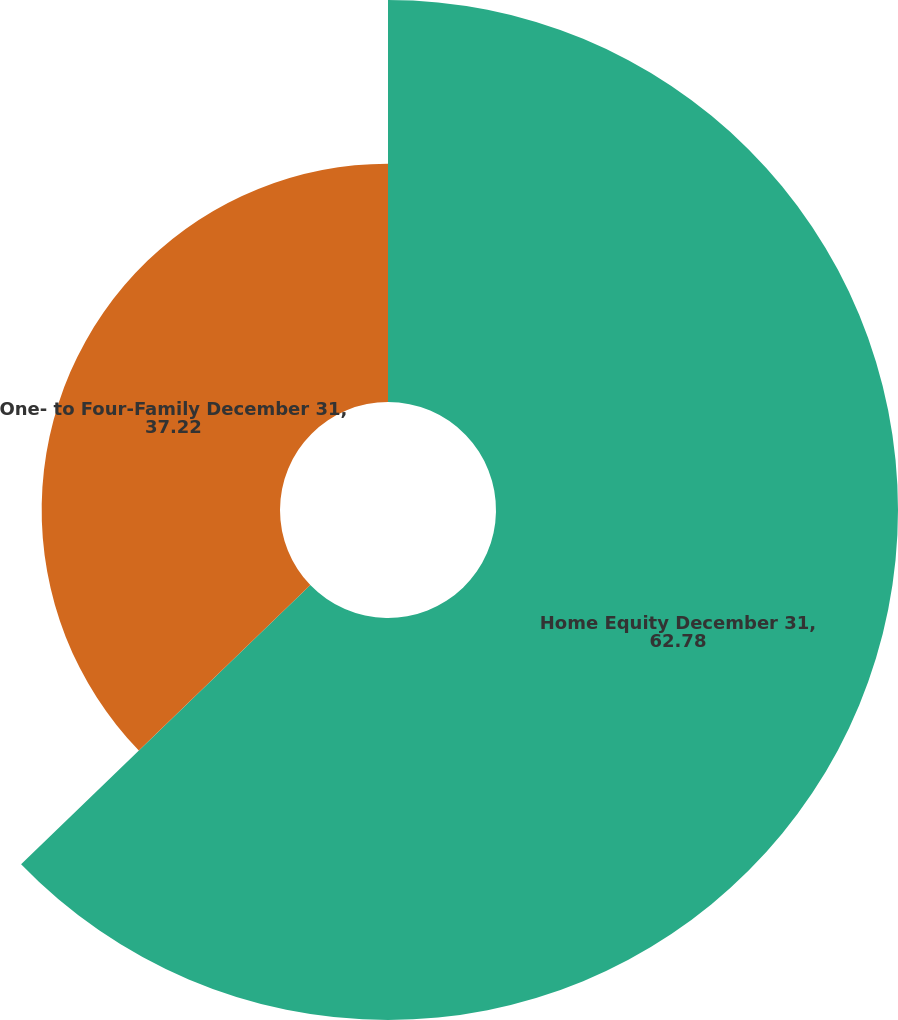<chart> <loc_0><loc_0><loc_500><loc_500><pie_chart><fcel>Home Equity December 31,<fcel>One- to Four-Family December 31,<nl><fcel>62.78%<fcel>37.22%<nl></chart> 